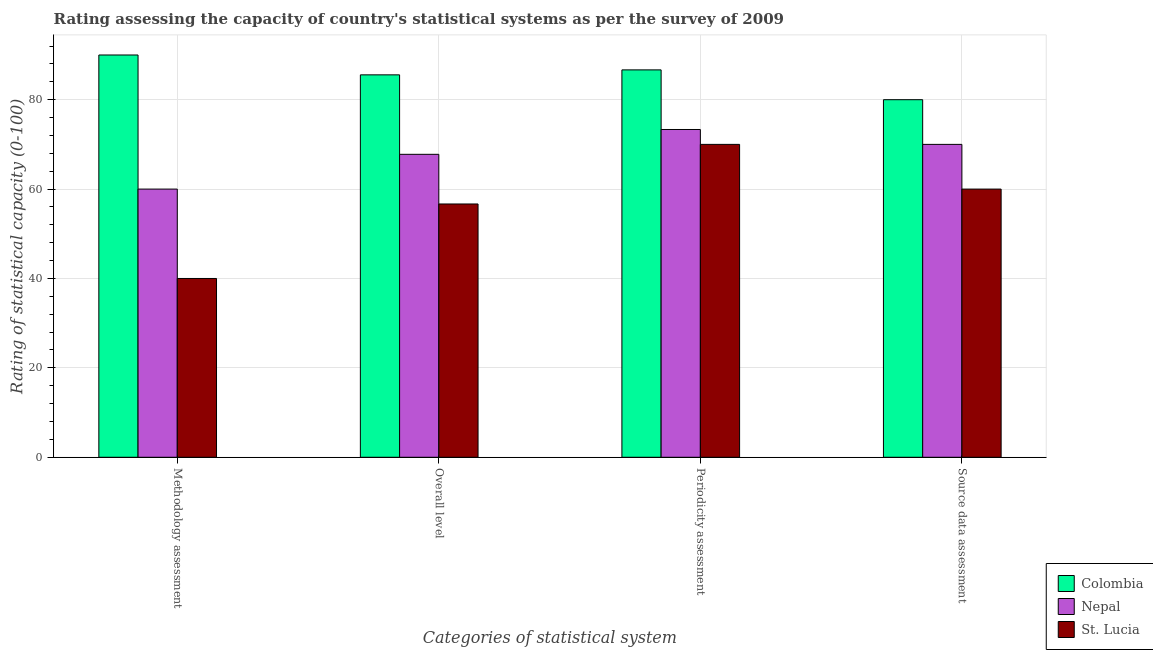Are the number of bars per tick equal to the number of legend labels?
Keep it short and to the point. Yes. Are the number of bars on each tick of the X-axis equal?
Offer a very short reply. Yes. What is the label of the 4th group of bars from the left?
Offer a very short reply. Source data assessment. Across all countries, what is the maximum overall level rating?
Ensure brevity in your answer.  85.56. Across all countries, what is the minimum overall level rating?
Make the answer very short. 56.67. In which country was the periodicity assessment rating minimum?
Provide a short and direct response. St. Lucia. What is the total source data assessment rating in the graph?
Provide a short and direct response. 210. What is the difference between the methodology assessment rating in Nepal and the periodicity assessment rating in Colombia?
Your answer should be compact. -26.67. What is the average overall level rating per country?
Your response must be concise. 70. What is the difference between the source data assessment rating and periodicity assessment rating in St. Lucia?
Give a very brief answer. -10. What is the ratio of the periodicity assessment rating in Colombia to that in St. Lucia?
Your answer should be very brief. 1.24. Is the difference between the methodology assessment rating in St. Lucia and Colombia greater than the difference between the periodicity assessment rating in St. Lucia and Colombia?
Your answer should be compact. No. What is the difference between the highest and the second highest methodology assessment rating?
Make the answer very short. 30. What is the difference between the highest and the lowest overall level rating?
Offer a very short reply. 28.89. In how many countries, is the overall level rating greater than the average overall level rating taken over all countries?
Make the answer very short. 1. Is it the case that in every country, the sum of the periodicity assessment rating and methodology assessment rating is greater than the sum of overall level rating and source data assessment rating?
Make the answer very short. No. What does the 3rd bar from the left in Source data assessment represents?
Keep it short and to the point. St. Lucia. What does the 2nd bar from the right in Periodicity assessment represents?
Provide a short and direct response. Nepal. Is it the case that in every country, the sum of the methodology assessment rating and overall level rating is greater than the periodicity assessment rating?
Your answer should be compact. Yes. Are all the bars in the graph horizontal?
Your response must be concise. No. Are the values on the major ticks of Y-axis written in scientific E-notation?
Ensure brevity in your answer.  No. Does the graph contain any zero values?
Offer a terse response. No. What is the title of the graph?
Ensure brevity in your answer.  Rating assessing the capacity of country's statistical systems as per the survey of 2009 . Does "Colombia" appear as one of the legend labels in the graph?
Your answer should be compact. Yes. What is the label or title of the X-axis?
Give a very brief answer. Categories of statistical system. What is the label or title of the Y-axis?
Offer a very short reply. Rating of statistical capacity (0-100). What is the Rating of statistical capacity (0-100) of Nepal in Methodology assessment?
Make the answer very short. 60. What is the Rating of statistical capacity (0-100) of Colombia in Overall level?
Provide a short and direct response. 85.56. What is the Rating of statistical capacity (0-100) of Nepal in Overall level?
Your answer should be very brief. 67.78. What is the Rating of statistical capacity (0-100) in St. Lucia in Overall level?
Offer a very short reply. 56.67. What is the Rating of statistical capacity (0-100) of Colombia in Periodicity assessment?
Provide a short and direct response. 86.67. What is the Rating of statistical capacity (0-100) in Nepal in Periodicity assessment?
Your answer should be very brief. 73.33. What is the Rating of statistical capacity (0-100) in Nepal in Source data assessment?
Offer a terse response. 70. Across all Categories of statistical system, what is the maximum Rating of statistical capacity (0-100) in Colombia?
Provide a short and direct response. 90. Across all Categories of statistical system, what is the maximum Rating of statistical capacity (0-100) of Nepal?
Your answer should be very brief. 73.33. Across all Categories of statistical system, what is the maximum Rating of statistical capacity (0-100) in St. Lucia?
Give a very brief answer. 70. Across all Categories of statistical system, what is the minimum Rating of statistical capacity (0-100) in Colombia?
Give a very brief answer. 80. Across all Categories of statistical system, what is the minimum Rating of statistical capacity (0-100) of St. Lucia?
Make the answer very short. 40. What is the total Rating of statistical capacity (0-100) of Colombia in the graph?
Make the answer very short. 342.22. What is the total Rating of statistical capacity (0-100) of Nepal in the graph?
Ensure brevity in your answer.  271.11. What is the total Rating of statistical capacity (0-100) in St. Lucia in the graph?
Give a very brief answer. 226.67. What is the difference between the Rating of statistical capacity (0-100) of Colombia in Methodology assessment and that in Overall level?
Give a very brief answer. 4.44. What is the difference between the Rating of statistical capacity (0-100) in Nepal in Methodology assessment and that in Overall level?
Ensure brevity in your answer.  -7.78. What is the difference between the Rating of statistical capacity (0-100) of St. Lucia in Methodology assessment and that in Overall level?
Provide a succinct answer. -16.67. What is the difference between the Rating of statistical capacity (0-100) in Nepal in Methodology assessment and that in Periodicity assessment?
Provide a succinct answer. -13.33. What is the difference between the Rating of statistical capacity (0-100) in Colombia in Overall level and that in Periodicity assessment?
Provide a short and direct response. -1.11. What is the difference between the Rating of statistical capacity (0-100) of Nepal in Overall level and that in Periodicity assessment?
Make the answer very short. -5.56. What is the difference between the Rating of statistical capacity (0-100) in St. Lucia in Overall level and that in Periodicity assessment?
Provide a succinct answer. -13.33. What is the difference between the Rating of statistical capacity (0-100) of Colombia in Overall level and that in Source data assessment?
Make the answer very short. 5.56. What is the difference between the Rating of statistical capacity (0-100) in Nepal in Overall level and that in Source data assessment?
Keep it short and to the point. -2.22. What is the difference between the Rating of statistical capacity (0-100) in Colombia in Methodology assessment and the Rating of statistical capacity (0-100) in Nepal in Overall level?
Your answer should be compact. 22.22. What is the difference between the Rating of statistical capacity (0-100) in Colombia in Methodology assessment and the Rating of statistical capacity (0-100) in St. Lucia in Overall level?
Your answer should be very brief. 33.33. What is the difference between the Rating of statistical capacity (0-100) in Nepal in Methodology assessment and the Rating of statistical capacity (0-100) in St. Lucia in Overall level?
Make the answer very short. 3.33. What is the difference between the Rating of statistical capacity (0-100) of Colombia in Methodology assessment and the Rating of statistical capacity (0-100) of Nepal in Periodicity assessment?
Give a very brief answer. 16.67. What is the difference between the Rating of statistical capacity (0-100) of Nepal in Methodology assessment and the Rating of statistical capacity (0-100) of St. Lucia in Source data assessment?
Offer a very short reply. 0. What is the difference between the Rating of statistical capacity (0-100) of Colombia in Overall level and the Rating of statistical capacity (0-100) of Nepal in Periodicity assessment?
Your answer should be compact. 12.22. What is the difference between the Rating of statistical capacity (0-100) of Colombia in Overall level and the Rating of statistical capacity (0-100) of St. Lucia in Periodicity assessment?
Provide a succinct answer. 15.56. What is the difference between the Rating of statistical capacity (0-100) in Nepal in Overall level and the Rating of statistical capacity (0-100) in St. Lucia in Periodicity assessment?
Give a very brief answer. -2.22. What is the difference between the Rating of statistical capacity (0-100) in Colombia in Overall level and the Rating of statistical capacity (0-100) in Nepal in Source data assessment?
Your answer should be very brief. 15.56. What is the difference between the Rating of statistical capacity (0-100) in Colombia in Overall level and the Rating of statistical capacity (0-100) in St. Lucia in Source data assessment?
Ensure brevity in your answer.  25.56. What is the difference between the Rating of statistical capacity (0-100) of Nepal in Overall level and the Rating of statistical capacity (0-100) of St. Lucia in Source data assessment?
Offer a terse response. 7.78. What is the difference between the Rating of statistical capacity (0-100) in Colombia in Periodicity assessment and the Rating of statistical capacity (0-100) in Nepal in Source data assessment?
Offer a very short reply. 16.67. What is the difference between the Rating of statistical capacity (0-100) of Colombia in Periodicity assessment and the Rating of statistical capacity (0-100) of St. Lucia in Source data assessment?
Your answer should be compact. 26.67. What is the difference between the Rating of statistical capacity (0-100) in Nepal in Periodicity assessment and the Rating of statistical capacity (0-100) in St. Lucia in Source data assessment?
Give a very brief answer. 13.33. What is the average Rating of statistical capacity (0-100) of Colombia per Categories of statistical system?
Make the answer very short. 85.56. What is the average Rating of statistical capacity (0-100) in Nepal per Categories of statistical system?
Offer a terse response. 67.78. What is the average Rating of statistical capacity (0-100) of St. Lucia per Categories of statistical system?
Give a very brief answer. 56.67. What is the difference between the Rating of statistical capacity (0-100) of Colombia and Rating of statistical capacity (0-100) of St. Lucia in Methodology assessment?
Provide a short and direct response. 50. What is the difference between the Rating of statistical capacity (0-100) in Nepal and Rating of statistical capacity (0-100) in St. Lucia in Methodology assessment?
Your answer should be very brief. 20. What is the difference between the Rating of statistical capacity (0-100) in Colombia and Rating of statistical capacity (0-100) in Nepal in Overall level?
Provide a short and direct response. 17.78. What is the difference between the Rating of statistical capacity (0-100) of Colombia and Rating of statistical capacity (0-100) of St. Lucia in Overall level?
Your response must be concise. 28.89. What is the difference between the Rating of statistical capacity (0-100) in Nepal and Rating of statistical capacity (0-100) in St. Lucia in Overall level?
Offer a very short reply. 11.11. What is the difference between the Rating of statistical capacity (0-100) in Colombia and Rating of statistical capacity (0-100) in Nepal in Periodicity assessment?
Make the answer very short. 13.33. What is the difference between the Rating of statistical capacity (0-100) of Colombia and Rating of statistical capacity (0-100) of St. Lucia in Periodicity assessment?
Keep it short and to the point. 16.67. What is the difference between the Rating of statistical capacity (0-100) of Colombia and Rating of statistical capacity (0-100) of Nepal in Source data assessment?
Make the answer very short. 10. What is the difference between the Rating of statistical capacity (0-100) of Nepal and Rating of statistical capacity (0-100) of St. Lucia in Source data assessment?
Your response must be concise. 10. What is the ratio of the Rating of statistical capacity (0-100) in Colombia in Methodology assessment to that in Overall level?
Your answer should be very brief. 1.05. What is the ratio of the Rating of statistical capacity (0-100) of Nepal in Methodology assessment to that in Overall level?
Your answer should be compact. 0.89. What is the ratio of the Rating of statistical capacity (0-100) of St. Lucia in Methodology assessment to that in Overall level?
Make the answer very short. 0.71. What is the ratio of the Rating of statistical capacity (0-100) of Nepal in Methodology assessment to that in Periodicity assessment?
Offer a terse response. 0.82. What is the ratio of the Rating of statistical capacity (0-100) of St. Lucia in Methodology assessment to that in Periodicity assessment?
Give a very brief answer. 0.57. What is the ratio of the Rating of statistical capacity (0-100) of Colombia in Methodology assessment to that in Source data assessment?
Give a very brief answer. 1.12. What is the ratio of the Rating of statistical capacity (0-100) in Nepal in Methodology assessment to that in Source data assessment?
Offer a very short reply. 0.86. What is the ratio of the Rating of statistical capacity (0-100) of St. Lucia in Methodology assessment to that in Source data assessment?
Keep it short and to the point. 0.67. What is the ratio of the Rating of statistical capacity (0-100) of Colombia in Overall level to that in Periodicity assessment?
Give a very brief answer. 0.99. What is the ratio of the Rating of statistical capacity (0-100) in Nepal in Overall level to that in Periodicity assessment?
Provide a succinct answer. 0.92. What is the ratio of the Rating of statistical capacity (0-100) in St. Lucia in Overall level to that in Periodicity assessment?
Keep it short and to the point. 0.81. What is the ratio of the Rating of statistical capacity (0-100) in Colombia in Overall level to that in Source data assessment?
Your response must be concise. 1.07. What is the ratio of the Rating of statistical capacity (0-100) of Nepal in Overall level to that in Source data assessment?
Provide a succinct answer. 0.97. What is the ratio of the Rating of statistical capacity (0-100) in Colombia in Periodicity assessment to that in Source data assessment?
Offer a terse response. 1.08. What is the ratio of the Rating of statistical capacity (0-100) of Nepal in Periodicity assessment to that in Source data assessment?
Ensure brevity in your answer.  1.05. What is the difference between the highest and the second highest Rating of statistical capacity (0-100) of Colombia?
Offer a very short reply. 3.33. What is the difference between the highest and the second highest Rating of statistical capacity (0-100) of St. Lucia?
Ensure brevity in your answer.  10. What is the difference between the highest and the lowest Rating of statistical capacity (0-100) in Colombia?
Make the answer very short. 10. What is the difference between the highest and the lowest Rating of statistical capacity (0-100) in Nepal?
Offer a very short reply. 13.33. What is the difference between the highest and the lowest Rating of statistical capacity (0-100) in St. Lucia?
Keep it short and to the point. 30. 